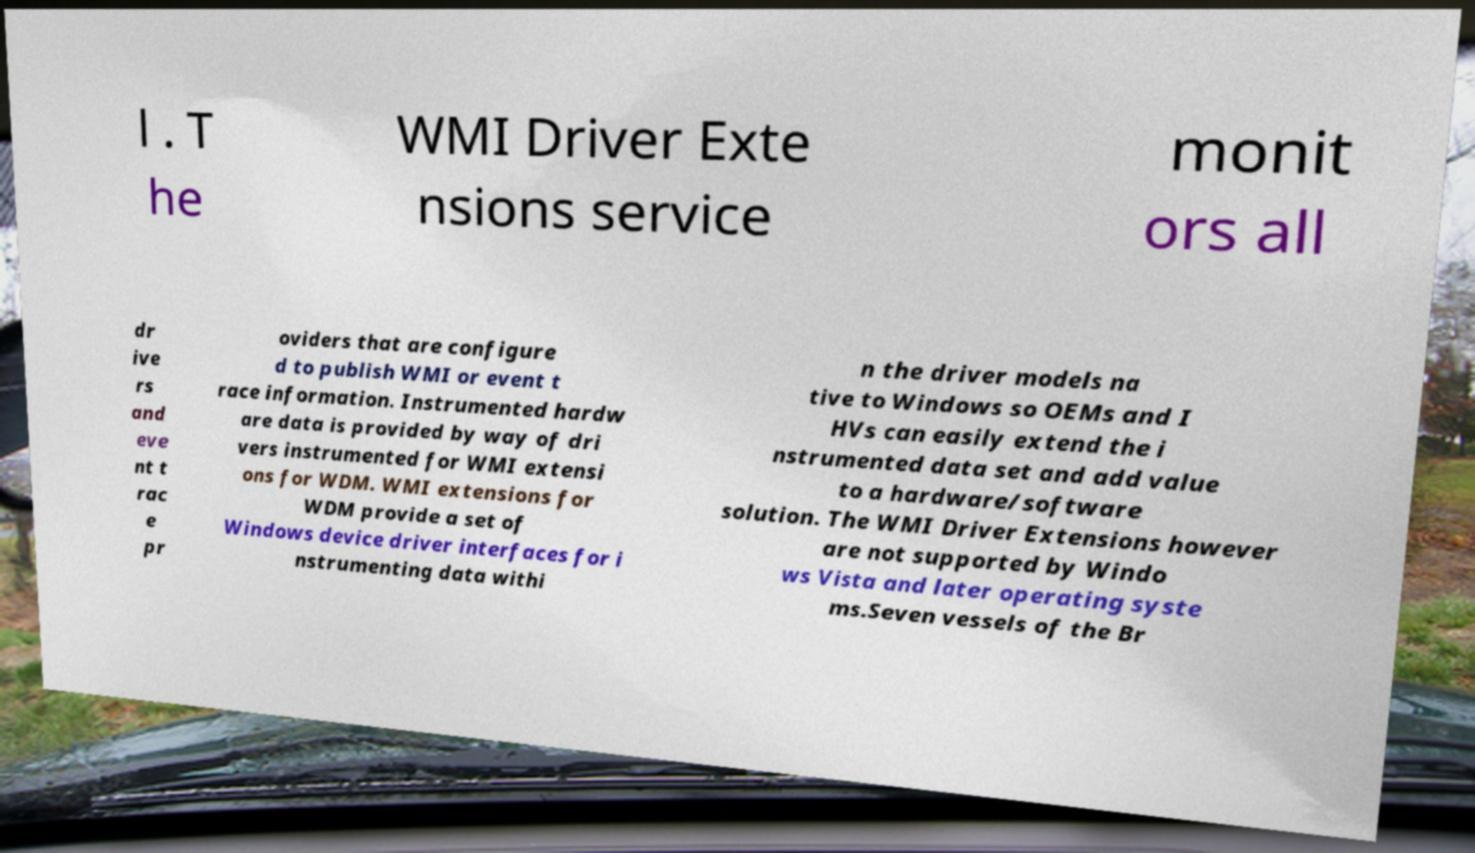Can you accurately transcribe the text from the provided image for me? l . T he WMI Driver Exte nsions service monit ors all dr ive rs and eve nt t rac e pr oviders that are configure d to publish WMI or event t race information. Instrumented hardw are data is provided by way of dri vers instrumented for WMI extensi ons for WDM. WMI extensions for WDM provide a set of Windows device driver interfaces for i nstrumenting data withi n the driver models na tive to Windows so OEMs and I HVs can easily extend the i nstrumented data set and add value to a hardware/software solution. The WMI Driver Extensions however are not supported by Windo ws Vista and later operating syste ms.Seven vessels of the Br 